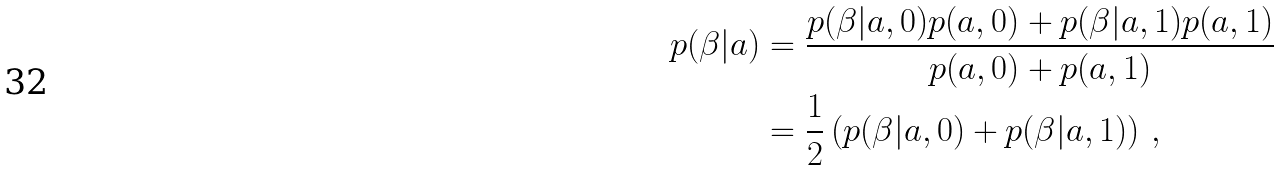<formula> <loc_0><loc_0><loc_500><loc_500>p ( \beta | a ) & = \frac { p ( \beta | a , 0 ) p ( a , 0 ) + p ( \beta | a , 1 ) p ( a , 1 ) } { p ( a , 0 ) + p ( a , 1 ) } \\ & = \frac { 1 } { 2 } \left ( p ( \beta | a , 0 ) + p ( \beta | a , 1 ) \right ) \, ,</formula> 